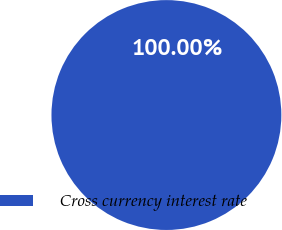Convert chart to OTSL. <chart><loc_0><loc_0><loc_500><loc_500><pie_chart><fcel>Cross currency interest rate<nl><fcel>100.0%<nl></chart> 